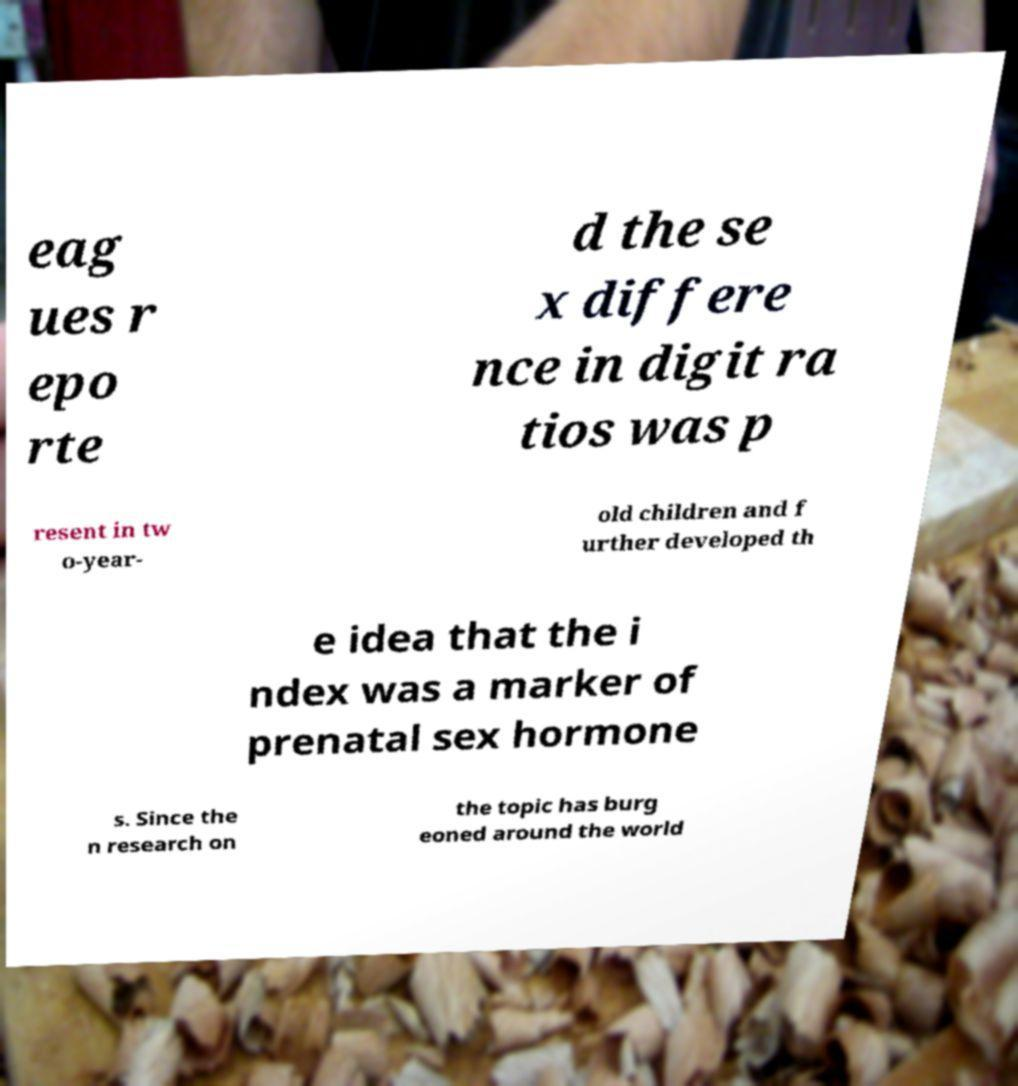There's text embedded in this image that I need extracted. Can you transcribe it verbatim? eag ues r epo rte d the se x differe nce in digit ra tios was p resent in tw o-year- old children and f urther developed th e idea that the i ndex was a marker of prenatal sex hormone s. Since the n research on the topic has burg eoned around the world 